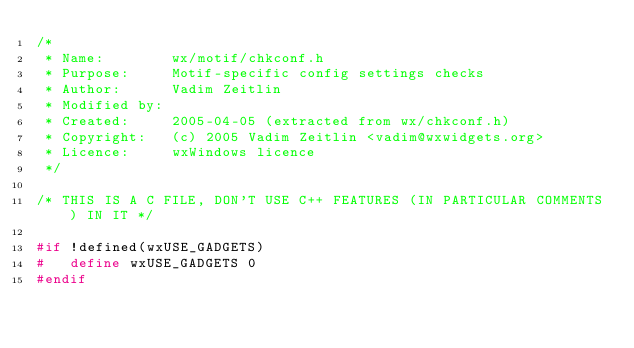Convert code to text. <code><loc_0><loc_0><loc_500><loc_500><_C_>/*
 * Name:        wx/motif/chkconf.h
 * Purpose:     Motif-specific config settings checks
 * Author:      Vadim Zeitlin
 * Modified by:
 * Created:     2005-04-05 (extracted from wx/chkconf.h)
 * Copyright:   (c) 2005 Vadim Zeitlin <vadim@wxwidgets.org>
 * Licence:     wxWindows licence
 */

/* THIS IS A C FILE, DON'T USE C++ FEATURES (IN PARTICULAR COMMENTS) IN IT */

#if !defined(wxUSE_GADGETS)
#   define wxUSE_GADGETS 0
#endif
</code> 